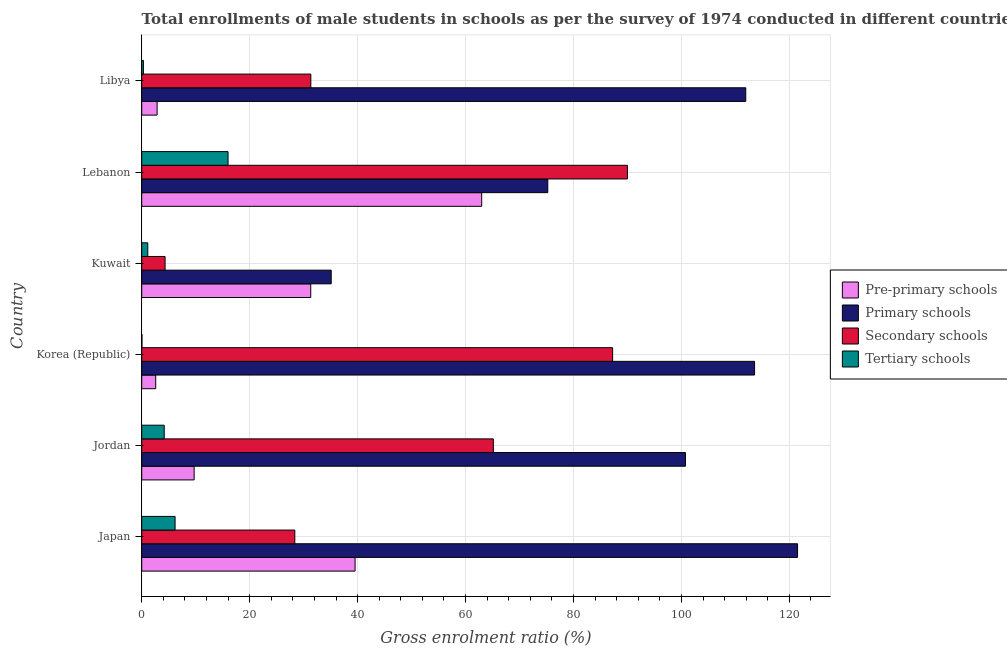How many groups of bars are there?
Offer a very short reply. 6. How many bars are there on the 5th tick from the top?
Your answer should be compact. 4. In how many cases, is the number of bars for a given country not equal to the number of legend labels?
Keep it short and to the point. 0. What is the gross enrolment ratio(male) in pre-primary schools in Jordan?
Offer a terse response. 9.71. Across all countries, what is the maximum gross enrolment ratio(male) in pre-primary schools?
Your answer should be very brief. 62.99. Across all countries, what is the minimum gross enrolment ratio(male) in pre-primary schools?
Provide a short and direct response. 2.59. In which country was the gross enrolment ratio(male) in secondary schools maximum?
Provide a short and direct response. Lebanon. In which country was the gross enrolment ratio(male) in tertiary schools minimum?
Ensure brevity in your answer.  Korea (Republic). What is the total gross enrolment ratio(male) in pre-primary schools in the graph?
Offer a terse response. 149. What is the difference between the gross enrolment ratio(male) in tertiary schools in Japan and that in Lebanon?
Give a very brief answer. -9.81. What is the difference between the gross enrolment ratio(male) in primary schools in Japan and the gross enrolment ratio(male) in pre-primary schools in Korea (Republic)?
Your answer should be compact. 118.92. What is the average gross enrolment ratio(male) in secondary schools per country?
Ensure brevity in your answer.  51.07. What is the difference between the gross enrolment ratio(male) in tertiary schools and gross enrolment ratio(male) in secondary schools in Korea (Republic)?
Your answer should be compact. -87.21. What is the ratio of the gross enrolment ratio(male) in tertiary schools in Japan to that in Jordan?
Provide a succinct answer. 1.48. Is the gross enrolment ratio(male) in tertiary schools in Jordan less than that in Lebanon?
Offer a very short reply. Yes. Is the difference between the gross enrolment ratio(male) in primary schools in Korea (Republic) and Kuwait greater than the difference between the gross enrolment ratio(male) in pre-primary schools in Korea (Republic) and Kuwait?
Offer a terse response. Yes. What is the difference between the highest and the second highest gross enrolment ratio(male) in pre-primary schools?
Your answer should be compact. 23.46. What is the difference between the highest and the lowest gross enrolment ratio(male) in tertiary schools?
Keep it short and to the point. 15.95. What does the 1st bar from the top in Jordan represents?
Your answer should be compact. Tertiary schools. What does the 4th bar from the bottom in Korea (Republic) represents?
Ensure brevity in your answer.  Tertiary schools. Is it the case that in every country, the sum of the gross enrolment ratio(male) in pre-primary schools and gross enrolment ratio(male) in primary schools is greater than the gross enrolment ratio(male) in secondary schools?
Make the answer very short. Yes. How many bars are there?
Provide a succinct answer. 24. Are the values on the major ticks of X-axis written in scientific E-notation?
Offer a terse response. No. Does the graph contain grids?
Make the answer very short. Yes. How many legend labels are there?
Your answer should be very brief. 4. How are the legend labels stacked?
Your response must be concise. Vertical. What is the title of the graph?
Offer a very short reply. Total enrollments of male students in schools as per the survey of 1974 conducted in different countries. Does "WFP" appear as one of the legend labels in the graph?
Offer a very short reply. No. What is the label or title of the X-axis?
Ensure brevity in your answer.  Gross enrolment ratio (%). What is the label or title of the Y-axis?
Your answer should be compact. Country. What is the Gross enrolment ratio (%) in Pre-primary schools in Japan?
Offer a very short reply. 39.53. What is the Gross enrolment ratio (%) in Primary schools in Japan?
Ensure brevity in your answer.  121.52. What is the Gross enrolment ratio (%) in Secondary schools in Japan?
Offer a terse response. 28.36. What is the Gross enrolment ratio (%) of Tertiary schools in Japan?
Keep it short and to the point. 6.18. What is the Gross enrolment ratio (%) in Pre-primary schools in Jordan?
Offer a very short reply. 9.71. What is the Gross enrolment ratio (%) of Primary schools in Jordan?
Keep it short and to the point. 100.75. What is the Gross enrolment ratio (%) in Secondary schools in Jordan?
Make the answer very short. 65.15. What is the Gross enrolment ratio (%) of Tertiary schools in Jordan?
Give a very brief answer. 4.17. What is the Gross enrolment ratio (%) in Pre-primary schools in Korea (Republic)?
Your answer should be compact. 2.59. What is the Gross enrolment ratio (%) of Primary schools in Korea (Republic)?
Offer a terse response. 113.55. What is the Gross enrolment ratio (%) of Secondary schools in Korea (Republic)?
Ensure brevity in your answer.  87.25. What is the Gross enrolment ratio (%) in Tertiary schools in Korea (Republic)?
Your answer should be compact. 0.04. What is the Gross enrolment ratio (%) of Pre-primary schools in Kuwait?
Make the answer very short. 31.32. What is the Gross enrolment ratio (%) of Primary schools in Kuwait?
Ensure brevity in your answer.  35.11. What is the Gross enrolment ratio (%) in Secondary schools in Kuwait?
Ensure brevity in your answer.  4.33. What is the Gross enrolment ratio (%) of Tertiary schools in Kuwait?
Your response must be concise. 1.12. What is the Gross enrolment ratio (%) of Pre-primary schools in Lebanon?
Offer a very short reply. 62.99. What is the Gross enrolment ratio (%) in Primary schools in Lebanon?
Make the answer very short. 75.24. What is the Gross enrolment ratio (%) in Secondary schools in Lebanon?
Offer a very short reply. 89.99. What is the Gross enrolment ratio (%) in Tertiary schools in Lebanon?
Your response must be concise. 16. What is the Gross enrolment ratio (%) of Pre-primary schools in Libya?
Your answer should be very brief. 2.85. What is the Gross enrolment ratio (%) in Primary schools in Libya?
Provide a succinct answer. 111.92. What is the Gross enrolment ratio (%) in Secondary schools in Libya?
Your response must be concise. 31.33. What is the Gross enrolment ratio (%) in Tertiary schools in Libya?
Provide a succinct answer. 0.32. Across all countries, what is the maximum Gross enrolment ratio (%) of Pre-primary schools?
Your answer should be compact. 62.99. Across all countries, what is the maximum Gross enrolment ratio (%) of Primary schools?
Your response must be concise. 121.52. Across all countries, what is the maximum Gross enrolment ratio (%) of Secondary schools?
Offer a terse response. 89.99. Across all countries, what is the maximum Gross enrolment ratio (%) in Tertiary schools?
Give a very brief answer. 16. Across all countries, what is the minimum Gross enrolment ratio (%) of Pre-primary schools?
Provide a succinct answer. 2.59. Across all countries, what is the minimum Gross enrolment ratio (%) in Primary schools?
Your answer should be very brief. 35.11. Across all countries, what is the minimum Gross enrolment ratio (%) of Secondary schools?
Provide a short and direct response. 4.33. Across all countries, what is the minimum Gross enrolment ratio (%) of Tertiary schools?
Offer a very short reply. 0.04. What is the total Gross enrolment ratio (%) of Pre-primary schools in the graph?
Your response must be concise. 149. What is the total Gross enrolment ratio (%) in Primary schools in the graph?
Make the answer very short. 558.09. What is the total Gross enrolment ratio (%) of Secondary schools in the graph?
Your response must be concise. 306.42. What is the total Gross enrolment ratio (%) of Tertiary schools in the graph?
Your answer should be compact. 27.83. What is the difference between the Gross enrolment ratio (%) in Pre-primary schools in Japan and that in Jordan?
Offer a terse response. 29.82. What is the difference between the Gross enrolment ratio (%) in Primary schools in Japan and that in Jordan?
Your answer should be very brief. 20.77. What is the difference between the Gross enrolment ratio (%) of Secondary schools in Japan and that in Jordan?
Offer a very short reply. -36.78. What is the difference between the Gross enrolment ratio (%) of Tertiary schools in Japan and that in Jordan?
Your answer should be compact. 2.01. What is the difference between the Gross enrolment ratio (%) of Pre-primary schools in Japan and that in Korea (Republic)?
Provide a succinct answer. 36.94. What is the difference between the Gross enrolment ratio (%) of Primary schools in Japan and that in Korea (Republic)?
Keep it short and to the point. 7.97. What is the difference between the Gross enrolment ratio (%) of Secondary schools in Japan and that in Korea (Republic)?
Offer a very short reply. -58.89. What is the difference between the Gross enrolment ratio (%) in Tertiary schools in Japan and that in Korea (Republic)?
Provide a short and direct response. 6.14. What is the difference between the Gross enrolment ratio (%) of Pre-primary schools in Japan and that in Kuwait?
Ensure brevity in your answer.  8.21. What is the difference between the Gross enrolment ratio (%) in Primary schools in Japan and that in Kuwait?
Keep it short and to the point. 86.41. What is the difference between the Gross enrolment ratio (%) in Secondary schools in Japan and that in Kuwait?
Your answer should be very brief. 24.04. What is the difference between the Gross enrolment ratio (%) of Tertiary schools in Japan and that in Kuwait?
Provide a short and direct response. 5.06. What is the difference between the Gross enrolment ratio (%) of Pre-primary schools in Japan and that in Lebanon?
Ensure brevity in your answer.  -23.46. What is the difference between the Gross enrolment ratio (%) in Primary schools in Japan and that in Lebanon?
Your answer should be compact. 46.28. What is the difference between the Gross enrolment ratio (%) in Secondary schools in Japan and that in Lebanon?
Your response must be concise. -61.63. What is the difference between the Gross enrolment ratio (%) in Tertiary schools in Japan and that in Lebanon?
Provide a succinct answer. -9.81. What is the difference between the Gross enrolment ratio (%) in Pre-primary schools in Japan and that in Libya?
Offer a terse response. 36.68. What is the difference between the Gross enrolment ratio (%) of Primary schools in Japan and that in Libya?
Your answer should be very brief. 9.6. What is the difference between the Gross enrolment ratio (%) of Secondary schools in Japan and that in Libya?
Ensure brevity in your answer.  -2.97. What is the difference between the Gross enrolment ratio (%) in Tertiary schools in Japan and that in Libya?
Make the answer very short. 5.87. What is the difference between the Gross enrolment ratio (%) of Pre-primary schools in Jordan and that in Korea (Republic)?
Your answer should be compact. 7.12. What is the difference between the Gross enrolment ratio (%) in Primary schools in Jordan and that in Korea (Republic)?
Give a very brief answer. -12.8. What is the difference between the Gross enrolment ratio (%) of Secondary schools in Jordan and that in Korea (Republic)?
Your response must be concise. -22.1. What is the difference between the Gross enrolment ratio (%) in Tertiary schools in Jordan and that in Korea (Republic)?
Provide a succinct answer. 4.13. What is the difference between the Gross enrolment ratio (%) in Pre-primary schools in Jordan and that in Kuwait?
Make the answer very short. -21.61. What is the difference between the Gross enrolment ratio (%) of Primary schools in Jordan and that in Kuwait?
Offer a very short reply. 65.64. What is the difference between the Gross enrolment ratio (%) of Secondary schools in Jordan and that in Kuwait?
Your answer should be compact. 60.82. What is the difference between the Gross enrolment ratio (%) in Tertiary schools in Jordan and that in Kuwait?
Your answer should be very brief. 3.05. What is the difference between the Gross enrolment ratio (%) in Pre-primary schools in Jordan and that in Lebanon?
Offer a terse response. -53.28. What is the difference between the Gross enrolment ratio (%) of Primary schools in Jordan and that in Lebanon?
Provide a succinct answer. 25.51. What is the difference between the Gross enrolment ratio (%) in Secondary schools in Jordan and that in Lebanon?
Provide a succinct answer. -24.84. What is the difference between the Gross enrolment ratio (%) in Tertiary schools in Jordan and that in Lebanon?
Make the answer very short. -11.83. What is the difference between the Gross enrolment ratio (%) of Pre-primary schools in Jordan and that in Libya?
Provide a short and direct response. 6.86. What is the difference between the Gross enrolment ratio (%) in Primary schools in Jordan and that in Libya?
Your answer should be compact. -11.17. What is the difference between the Gross enrolment ratio (%) of Secondary schools in Jordan and that in Libya?
Make the answer very short. 33.82. What is the difference between the Gross enrolment ratio (%) of Tertiary schools in Jordan and that in Libya?
Provide a short and direct response. 3.85. What is the difference between the Gross enrolment ratio (%) of Pre-primary schools in Korea (Republic) and that in Kuwait?
Provide a short and direct response. -28.72. What is the difference between the Gross enrolment ratio (%) in Primary schools in Korea (Republic) and that in Kuwait?
Your response must be concise. 78.44. What is the difference between the Gross enrolment ratio (%) in Secondary schools in Korea (Republic) and that in Kuwait?
Keep it short and to the point. 82.92. What is the difference between the Gross enrolment ratio (%) in Tertiary schools in Korea (Republic) and that in Kuwait?
Provide a short and direct response. -1.08. What is the difference between the Gross enrolment ratio (%) of Pre-primary schools in Korea (Republic) and that in Lebanon?
Offer a terse response. -60.4. What is the difference between the Gross enrolment ratio (%) of Primary schools in Korea (Republic) and that in Lebanon?
Provide a succinct answer. 38.31. What is the difference between the Gross enrolment ratio (%) of Secondary schools in Korea (Republic) and that in Lebanon?
Make the answer very short. -2.74. What is the difference between the Gross enrolment ratio (%) in Tertiary schools in Korea (Republic) and that in Lebanon?
Your answer should be very brief. -15.95. What is the difference between the Gross enrolment ratio (%) of Pre-primary schools in Korea (Republic) and that in Libya?
Your answer should be very brief. -0.26. What is the difference between the Gross enrolment ratio (%) of Primary schools in Korea (Republic) and that in Libya?
Your answer should be very brief. 1.63. What is the difference between the Gross enrolment ratio (%) in Secondary schools in Korea (Republic) and that in Libya?
Your answer should be compact. 55.92. What is the difference between the Gross enrolment ratio (%) in Tertiary schools in Korea (Republic) and that in Libya?
Your answer should be very brief. -0.27. What is the difference between the Gross enrolment ratio (%) in Pre-primary schools in Kuwait and that in Lebanon?
Keep it short and to the point. -31.68. What is the difference between the Gross enrolment ratio (%) of Primary schools in Kuwait and that in Lebanon?
Provide a short and direct response. -40.13. What is the difference between the Gross enrolment ratio (%) in Secondary schools in Kuwait and that in Lebanon?
Keep it short and to the point. -85.67. What is the difference between the Gross enrolment ratio (%) in Tertiary schools in Kuwait and that in Lebanon?
Your response must be concise. -14.87. What is the difference between the Gross enrolment ratio (%) of Pre-primary schools in Kuwait and that in Libya?
Keep it short and to the point. 28.47. What is the difference between the Gross enrolment ratio (%) in Primary schools in Kuwait and that in Libya?
Offer a terse response. -76.81. What is the difference between the Gross enrolment ratio (%) of Secondary schools in Kuwait and that in Libya?
Provide a short and direct response. -27.01. What is the difference between the Gross enrolment ratio (%) of Tertiary schools in Kuwait and that in Libya?
Provide a succinct answer. 0.81. What is the difference between the Gross enrolment ratio (%) in Pre-primary schools in Lebanon and that in Libya?
Offer a very short reply. 60.14. What is the difference between the Gross enrolment ratio (%) of Primary schools in Lebanon and that in Libya?
Ensure brevity in your answer.  -36.68. What is the difference between the Gross enrolment ratio (%) of Secondary schools in Lebanon and that in Libya?
Your answer should be very brief. 58.66. What is the difference between the Gross enrolment ratio (%) of Tertiary schools in Lebanon and that in Libya?
Your response must be concise. 15.68. What is the difference between the Gross enrolment ratio (%) in Pre-primary schools in Japan and the Gross enrolment ratio (%) in Primary schools in Jordan?
Offer a very short reply. -61.22. What is the difference between the Gross enrolment ratio (%) of Pre-primary schools in Japan and the Gross enrolment ratio (%) of Secondary schools in Jordan?
Provide a succinct answer. -25.62. What is the difference between the Gross enrolment ratio (%) of Pre-primary schools in Japan and the Gross enrolment ratio (%) of Tertiary schools in Jordan?
Give a very brief answer. 35.36. What is the difference between the Gross enrolment ratio (%) in Primary schools in Japan and the Gross enrolment ratio (%) in Secondary schools in Jordan?
Ensure brevity in your answer.  56.37. What is the difference between the Gross enrolment ratio (%) in Primary schools in Japan and the Gross enrolment ratio (%) in Tertiary schools in Jordan?
Your answer should be very brief. 117.35. What is the difference between the Gross enrolment ratio (%) of Secondary schools in Japan and the Gross enrolment ratio (%) of Tertiary schools in Jordan?
Provide a short and direct response. 24.2. What is the difference between the Gross enrolment ratio (%) in Pre-primary schools in Japan and the Gross enrolment ratio (%) in Primary schools in Korea (Republic)?
Offer a very short reply. -74.02. What is the difference between the Gross enrolment ratio (%) in Pre-primary schools in Japan and the Gross enrolment ratio (%) in Secondary schools in Korea (Republic)?
Your answer should be very brief. -47.72. What is the difference between the Gross enrolment ratio (%) in Pre-primary schools in Japan and the Gross enrolment ratio (%) in Tertiary schools in Korea (Republic)?
Your answer should be compact. 39.49. What is the difference between the Gross enrolment ratio (%) in Primary schools in Japan and the Gross enrolment ratio (%) in Secondary schools in Korea (Republic)?
Give a very brief answer. 34.27. What is the difference between the Gross enrolment ratio (%) of Primary schools in Japan and the Gross enrolment ratio (%) of Tertiary schools in Korea (Republic)?
Provide a short and direct response. 121.48. What is the difference between the Gross enrolment ratio (%) in Secondary schools in Japan and the Gross enrolment ratio (%) in Tertiary schools in Korea (Republic)?
Give a very brief answer. 28.32. What is the difference between the Gross enrolment ratio (%) of Pre-primary schools in Japan and the Gross enrolment ratio (%) of Primary schools in Kuwait?
Ensure brevity in your answer.  4.42. What is the difference between the Gross enrolment ratio (%) of Pre-primary schools in Japan and the Gross enrolment ratio (%) of Secondary schools in Kuwait?
Your answer should be compact. 35.2. What is the difference between the Gross enrolment ratio (%) of Pre-primary schools in Japan and the Gross enrolment ratio (%) of Tertiary schools in Kuwait?
Ensure brevity in your answer.  38.41. What is the difference between the Gross enrolment ratio (%) of Primary schools in Japan and the Gross enrolment ratio (%) of Secondary schools in Kuwait?
Offer a very short reply. 117.19. What is the difference between the Gross enrolment ratio (%) in Primary schools in Japan and the Gross enrolment ratio (%) in Tertiary schools in Kuwait?
Make the answer very short. 120.4. What is the difference between the Gross enrolment ratio (%) in Secondary schools in Japan and the Gross enrolment ratio (%) in Tertiary schools in Kuwait?
Provide a succinct answer. 27.24. What is the difference between the Gross enrolment ratio (%) in Pre-primary schools in Japan and the Gross enrolment ratio (%) in Primary schools in Lebanon?
Ensure brevity in your answer.  -35.71. What is the difference between the Gross enrolment ratio (%) in Pre-primary schools in Japan and the Gross enrolment ratio (%) in Secondary schools in Lebanon?
Your response must be concise. -50.46. What is the difference between the Gross enrolment ratio (%) of Pre-primary schools in Japan and the Gross enrolment ratio (%) of Tertiary schools in Lebanon?
Provide a succinct answer. 23.54. What is the difference between the Gross enrolment ratio (%) in Primary schools in Japan and the Gross enrolment ratio (%) in Secondary schools in Lebanon?
Offer a terse response. 31.52. What is the difference between the Gross enrolment ratio (%) in Primary schools in Japan and the Gross enrolment ratio (%) in Tertiary schools in Lebanon?
Ensure brevity in your answer.  105.52. What is the difference between the Gross enrolment ratio (%) of Secondary schools in Japan and the Gross enrolment ratio (%) of Tertiary schools in Lebanon?
Make the answer very short. 12.37. What is the difference between the Gross enrolment ratio (%) of Pre-primary schools in Japan and the Gross enrolment ratio (%) of Primary schools in Libya?
Provide a succinct answer. -72.39. What is the difference between the Gross enrolment ratio (%) in Pre-primary schools in Japan and the Gross enrolment ratio (%) in Secondary schools in Libya?
Offer a terse response. 8.2. What is the difference between the Gross enrolment ratio (%) in Pre-primary schools in Japan and the Gross enrolment ratio (%) in Tertiary schools in Libya?
Offer a very short reply. 39.22. What is the difference between the Gross enrolment ratio (%) of Primary schools in Japan and the Gross enrolment ratio (%) of Secondary schools in Libya?
Your answer should be very brief. 90.18. What is the difference between the Gross enrolment ratio (%) in Primary schools in Japan and the Gross enrolment ratio (%) in Tertiary schools in Libya?
Make the answer very short. 121.2. What is the difference between the Gross enrolment ratio (%) of Secondary schools in Japan and the Gross enrolment ratio (%) of Tertiary schools in Libya?
Offer a very short reply. 28.05. What is the difference between the Gross enrolment ratio (%) in Pre-primary schools in Jordan and the Gross enrolment ratio (%) in Primary schools in Korea (Republic)?
Offer a very short reply. -103.84. What is the difference between the Gross enrolment ratio (%) in Pre-primary schools in Jordan and the Gross enrolment ratio (%) in Secondary schools in Korea (Republic)?
Offer a very short reply. -77.54. What is the difference between the Gross enrolment ratio (%) in Pre-primary schools in Jordan and the Gross enrolment ratio (%) in Tertiary schools in Korea (Republic)?
Your answer should be compact. 9.67. What is the difference between the Gross enrolment ratio (%) of Primary schools in Jordan and the Gross enrolment ratio (%) of Secondary schools in Korea (Republic)?
Offer a very short reply. 13.5. What is the difference between the Gross enrolment ratio (%) of Primary schools in Jordan and the Gross enrolment ratio (%) of Tertiary schools in Korea (Republic)?
Your response must be concise. 100.71. What is the difference between the Gross enrolment ratio (%) in Secondary schools in Jordan and the Gross enrolment ratio (%) in Tertiary schools in Korea (Republic)?
Offer a terse response. 65.11. What is the difference between the Gross enrolment ratio (%) in Pre-primary schools in Jordan and the Gross enrolment ratio (%) in Primary schools in Kuwait?
Your response must be concise. -25.4. What is the difference between the Gross enrolment ratio (%) in Pre-primary schools in Jordan and the Gross enrolment ratio (%) in Secondary schools in Kuwait?
Offer a very short reply. 5.38. What is the difference between the Gross enrolment ratio (%) in Pre-primary schools in Jordan and the Gross enrolment ratio (%) in Tertiary schools in Kuwait?
Your answer should be compact. 8.59. What is the difference between the Gross enrolment ratio (%) in Primary schools in Jordan and the Gross enrolment ratio (%) in Secondary schools in Kuwait?
Make the answer very short. 96.42. What is the difference between the Gross enrolment ratio (%) in Primary schools in Jordan and the Gross enrolment ratio (%) in Tertiary schools in Kuwait?
Provide a succinct answer. 99.63. What is the difference between the Gross enrolment ratio (%) in Secondary schools in Jordan and the Gross enrolment ratio (%) in Tertiary schools in Kuwait?
Your answer should be compact. 64.03. What is the difference between the Gross enrolment ratio (%) in Pre-primary schools in Jordan and the Gross enrolment ratio (%) in Primary schools in Lebanon?
Make the answer very short. -65.53. What is the difference between the Gross enrolment ratio (%) in Pre-primary schools in Jordan and the Gross enrolment ratio (%) in Secondary schools in Lebanon?
Offer a terse response. -80.28. What is the difference between the Gross enrolment ratio (%) of Pre-primary schools in Jordan and the Gross enrolment ratio (%) of Tertiary schools in Lebanon?
Make the answer very short. -6.28. What is the difference between the Gross enrolment ratio (%) of Primary schools in Jordan and the Gross enrolment ratio (%) of Secondary schools in Lebanon?
Make the answer very short. 10.76. What is the difference between the Gross enrolment ratio (%) of Primary schools in Jordan and the Gross enrolment ratio (%) of Tertiary schools in Lebanon?
Your answer should be very brief. 84.75. What is the difference between the Gross enrolment ratio (%) in Secondary schools in Jordan and the Gross enrolment ratio (%) in Tertiary schools in Lebanon?
Offer a very short reply. 49.15. What is the difference between the Gross enrolment ratio (%) in Pre-primary schools in Jordan and the Gross enrolment ratio (%) in Primary schools in Libya?
Make the answer very short. -102.21. What is the difference between the Gross enrolment ratio (%) in Pre-primary schools in Jordan and the Gross enrolment ratio (%) in Secondary schools in Libya?
Give a very brief answer. -21.62. What is the difference between the Gross enrolment ratio (%) in Pre-primary schools in Jordan and the Gross enrolment ratio (%) in Tertiary schools in Libya?
Keep it short and to the point. 9.4. What is the difference between the Gross enrolment ratio (%) of Primary schools in Jordan and the Gross enrolment ratio (%) of Secondary schools in Libya?
Offer a very short reply. 69.42. What is the difference between the Gross enrolment ratio (%) in Primary schools in Jordan and the Gross enrolment ratio (%) in Tertiary schools in Libya?
Offer a terse response. 100.44. What is the difference between the Gross enrolment ratio (%) of Secondary schools in Jordan and the Gross enrolment ratio (%) of Tertiary schools in Libya?
Your answer should be compact. 64.83. What is the difference between the Gross enrolment ratio (%) of Pre-primary schools in Korea (Republic) and the Gross enrolment ratio (%) of Primary schools in Kuwait?
Offer a terse response. -32.52. What is the difference between the Gross enrolment ratio (%) of Pre-primary schools in Korea (Republic) and the Gross enrolment ratio (%) of Secondary schools in Kuwait?
Offer a very short reply. -1.73. What is the difference between the Gross enrolment ratio (%) of Pre-primary schools in Korea (Republic) and the Gross enrolment ratio (%) of Tertiary schools in Kuwait?
Give a very brief answer. 1.47. What is the difference between the Gross enrolment ratio (%) of Primary schools in Korea (Republic) and the Gross enrolment ratio (%) of Secondary schools in Kuwait?
Offer a very short reply. 109.22. What is the difference between the Gross enrolment ratio (%) in Primary schools in Korea (Republic) and the Gross enrolment ratio (%) in Tertiary schools in Kuwait?
Provide a succinct answer. 112.43. What is the difference between the Gross enrolment ratio (%) in Secondary schools in Korea (Republic) and the Gross enrolment ratio (%) in Tertiary schools in Kuwait?
Provide a short and direct response. 86.13. What is the difference between the Gross enrolment ratio (%) in Pre-primary schools in Korea (Republic) and the Gross enrolment ratio (%) in Primary schools in Lebanon?
Keep it short and to the point. -72.64. What is the difference between the Gross enrolment ratio (%) in Pre-primary schools in Korea (Republic) and the Gross enrolment ratio (%) in Secondary schools in Lebanon?
Your response must be concise. -87.4. What is the difference between the Gross enrolment ratio (%) of Pre-primary schools in Korea (Republic) and the Gross enrolment ratio (%) of Tertiary schools in Lebanon?
Provide a succinct answer. -13.4. What is the difference between the Gross enrolment ratio (%) of Primary schools in Korea (Republic) and the Gross enrolment ratio (%) of Secondary schools in Lebanon?
Offer a very short reply. 23.56. What is the difference between the Gross enrolment ratio (%) in Primary schools in Korea (Republic) and the Gross enrolment ratio (%) in Tertiary schools in Lebanon?
Offer a very short reply. 97.56. What is the difference between the Gross enrolment ratio (%) in Secondary schools in Korea (Republic) and the Gross enrolment ratio (%) in Tertiary schools in Lebanon?
Offer a terse response. 71.25. What is the difference between the Gross enrolment ratio (%) of Pre-primary schools in Korea (Republic) and the Gross enrolment ratio (%) of Primary schools in Libya?
Provide a short and direct response. -109.33. What is the difference between the Gross enrolment ratio (%) of Pre-primary schools in Korea (Republic) and the Gross enrolment ratio (%) of Secondary schools in Libya?
Offer a terse response. -28.74. What is the difference between the Gross enrolment ratio (%) in Pre-primary schools in Korea (Republic) and the Gross enrolment ratio (%) in Tertiary schools in Libya?
Ensure brevity in your answer.  2.28. What is the difference between the Gross enrolment ratio (%) of Primary schools in Korea (Republic) and the Gross enrolment ratio (%) of Secondary schools in Libya?
Provide a succinct answer. 82.22. What is the difference between the Gross enrolment ratio (%) in Primary schools in Korea (Republic) and the Gross enrolment ratio (%) in Tertiary schools in Libya?
Provide a short and direct response. 113.24. What is the difference between the Gross enrolment ratio (%) of Secondary schools in Korea (Republic) and the Gross enrolment ratio (%) of Tertiary schools in Libya?
Offer a very short reply. 86.94. What is the difference between the Gross enrolment ratio (%) in Pre-primary schools in Kuwait and the Gross enrolment ratio (%) in Primary schools in Lebanon?
Your answer should be compact. -43.92. What is the difference between the Gross enrolment ratio (%) in Pre-primary schools in Kuwait and the Gross enrolment ratio (%) in Secondary schools in Lebanon?
Your answer should be very brief. -58.68. What is the difference between the Gross enrolment ratio (%) of Pre-primary schools in Kuwait and the Gross enrolment ratio (%) of Tertiary schools in Lebanon?
Provide a succinct answer. 15.32. What is the difference between the Gross enrolment ratio (%) in Primary schools in Kuwait and the Gross enrolment ratio (%) in Secondary schools in Lebanon?
Your answer should be very brief. -54.88. What is the difference between the Gross enrolment ratio (%) of Primary schools in Kuwait and the Gross enrolment ratio (%) of Tertiary schools in Lebanon?
Your answer should be very brief. 19.11. What is the difference between the Gross enrolment ratio (%) of Secondary schools in Kuwait and the Gross enrolment ratio (%) of Tertiary schools in Lebanon?
Your response must be concise. -11.67. What is the difference between the Gross enrolment ratio (%) in Pre-primary schools in Kuwait and the Gross enrolment ratio (%) in Primary schools in Libya?
Offer a very short reply. -80.6. What is the difference between the Gross enrolment ratio (%) in Pre-primary schools in Kuwait and the Gross enrolment ratio (%) in Secondary schools in Libya?
Give a very brief answer. -0.02. What is the difference between the Gross enrolment ratio (%) in Pre-primary schools in Kuwait and the Gross enrolment ratio (%) in Tertiary schools in Libya?
Your answer should be compact. 31. What is the difference between the Gross enrolment ratio (%) in Primary schools in Kuwait and the Gross enrolment ratio (%) in Secondary schools in Libya?
Ensure brevity in your answer.  3.78. What is the difference between the Gross enrolment ratio (%) in Primary schools in Kuwait and the Gross enrolment ratio (%) in Tertiary schools in Libya?
Provide a short and direct response. 34.79. What is the difference between the Gross enrolment ratio (%) of Secondary schools in Kuwait and the Gross enrolment ratio (%) of Tertiary schools in Libya?
Provide a short and direct response. 4.01. What is the difference between the Gross enrolment ratio (%) in Pre-primary schools in Lebanon and the Gross enrolment ratio (%) in Primary schools in Libya?
Your response must be concise. -48.93. What is the difference between the Gross enrolment ratio (%) of Pre-primary schools in Lebanon and the Gross enrolment ratio (%) of Secondary schools in Libya?
Keep it short and to the point. 31.66. What is the difference between the Gross enrolment ratio (%) in Pre-primary schools in Lebanon and the Gross enrolment ratio (%) in Tertiary schools in Libya?
Provide a succinct answer. 62.68. What is the difference between the Gross enrolment ratio (%) in Primary schools in Lebanon and the Gross enrolment ratio (%) in Secondary schools in Libya?
Ensure brevity in your answer.  43.9. What is the difference between the Gross enrolment ratio (%) of Primary schools in Lebanon and the Gross enrolment ratio (%) of Tertiary schools in Libya?
Give a very brief answer. 74.92. What is the difference between the Gross enrolment ratio (%) in Secondary schools in Lebanon and the Gross enrolment ratio (%) in Tertiary schools in Libya?
Make the answer very short. 89.68. What is the average Gross enrolment ratio (%) of Pre-primary schools per country?
Keep it short and to the point. 24.83. What is the average Gross enrolment ratio (%) in Primary schools per country?
Give a very brief answer. 93.01. What is the average Gross enrolment ratio (%) of Secondary schools per country?
Make the answer very short. 51.07. What is the average Gross enrolment ratio (%) of Tertiary schools per country?
Give a very brief answer. 4.64. What is the difference between the Gross enrolment ratio (%) of Pre-primary schools and Gross enrolment ratio (%) of Primary schools in Japan?
Offer a very short reply. -81.99. What is the difference between the Gross enrolment ratio (%) in Pre-primary schools and Gross enrolment ratio (%) in Secondary schools in Japan?
Keep it short and to the point. 11.17. What is the difference between the Gross enrolment ratio (%) of Pre-primary schools and Gross enrolment ratio (%) of Tertiary schools in Japan?
Provide a succinct answer. 33.35. What is the difference between the Gross enrolment ratio (%) of Primary schools and Gross enrolment ratio (%) of Secondary schools in Japan?
Provide a succinct answer. 93.15. What is the difference between the Gross enrolment ratio (%) of Primary schools and Gross enrolment ratio (%) of Tertiary schools in Japan?
Offer a terse response. 115.34. What is the difference between the Gross enrolment ratio (%) of Secondary schools and Gross enrolment ratio (%) of Tertiary schools in Japan?
Offer a very short reply. 22.18. What is the difference between the Gross enrolment ratio (%) of Pre-primary schools and Gross enrolment ratio (%) of Primary schools in Jordan?
Make the answer very short. -91.04. What is the difference between the Gross enrolment ratio (%) of Pre-primary schools and Gross enrolment ratio (%) of Secondary schools in Jordan?
Ensure brevity in your answer.  -55.44. What is the difference between the Gross enrolment ratio (%) in Pre-primary schools and Gross enrolment ratio (%) in Tertiary schools in Jordan?
Ensure brevity in your answer.  5.54. What is the difference between the Gross enrolment ratio (%) in Primary schools and Gross enrolment ratio (%) in Secondary schools in Jordan?
Give a very brief answer. 35.6. What is the difference between the Gross enrolment ratio (%) of Primary schools and Gross enrolment ratio (%) of Tertiary schools in Jordan?
Your answer should be very brief. 96.58. What is the difference between the Gross enrolment ratio (%) in Secondary schools and Gross enrolment ratio (%) in Tertiary schools in Jordan?
Provide a succinct answer. 60.98. What is the difference between the Gross enrolment ratio (%) in Pre-primary schools and Gross enrolment ratio (%) in Primary schools in Korea (Republic)?
Keep it short and to the point. -110.96. What is the difference between the Gross enrolment ratio (%) in Pre-primary schools and Gross enrolment ratio (%) in Secondary schools in Korea (Republic)?
Ensure brevity in your answer.  -84.66. What is the difference between the Gross enrolment ratio (%) in Pre-primary schools and Gross enrolment ratio (%) in Tertiary schools in Korea (Republic)?
Offer a terse response. 2.55. What is the difference between the Gross enrolment ratio (%) of Primary schools and Gross enrolment ratio (%) of Secondary schools in Korea (Republic)?
Your response must be concise. 26.3. What is the difference between the Gross enrolment ratio (%) in Primary schools and Gross enrolment ratio (%) in Tertiary schools in Korea (Republic)?
Provide a short and direct response. 113.51. What is the difference between the Gross enrolment ratio (%) in Secondary schools and Gross enrolment ratio (%) in Tertiary schools in Korea (Republic)?
Your answer should be very brief. 87.21. What is the difference between the Gross enrolment ratio (%) in Pre-primary schools and Gross enrolment ratio (%) in Primary schools in Kuwait?
Ensure brevity in your answer.  -3.79. What is the difference between the Gross enrolment ratio (%) in Pre-primary schools and Gross enrolment ratio (%) in Secondary schools in Kuwait?
Provide a succinct answer. 26.99. What is the difference between the Gross enrolment ratio (%) of Pre-primary schools and Gross enrolment ratio (%) of Tertiary schools in Kuwait?
Ensure brevity in your answer.  30.2. What is the difference between the Gross enrolment ratio (%) of Primary schools and Gross enrolment ratio (%) of Secondary schools in Kuwait?
Your response must be concise. 30.78. What is the difference between the Gross enrolment ratio (%) in Primary schools and Gross enrolment ratio (%) in Tertiary schools in Kuwait?
Offer a terse response. 33.99. What is the difference between the Gross enrolment ratio (%) of Secondary schools and Gross enrolment ratio (%) of Tertiary schools in Kuwait?
Your answer should be compact. 3.21. What is the difference between the Gross enrolment ratio (%) in Pre-primary schools and Gross enrolment ratio (%) in Primary schools in Lebanon?
Provide a succinct answer. -12.24. What is the difference between the Gross enrolment ratio (%) of Pre-primary schools and Gross enrolment ratio (%) of Secondary schools in Lebanon?
Your answer should be compact. -27. What is the difference between the Gross enrolment ratio (%) of Pre-primary schools and Gross enrolment ratio (%) of Tertiary schools in Lebanon?
Provide a short and direct response. 47. What is the difference between the Gross enrolment ratio (%) in Primary schools and Gross enrolment ratio (%) in Secondary schools in Lebanon?
Ensure brevity in your answer.  -14.76. What is the difference between the Gross enrolment ratio (%) in Primary schools and Gross enrolment ratio (%) in Tertiary schools in Lebanon?
Give a very brief answer. 59.24. What is the difference between the Gross enrolment ratio (%) of Secondary schools and Gross enrolment ratio (%) of Tertiary schools in Lebanon?
Provide a short and direct response. 74. What is the difference between the Gross enrolment ratio (%) in Pre-primary schools and Gross enrolment ratio (%) in Primary schools in Libya?
Your answer should be compact. -109.07. What is the difference between the Gross enrolment ratio (%) in Pre-primary schools and Gross enrolment ratio (%) in Secondary schools in Libya?
Your answer should be compact. -28.48. What is the difference between the Gross enrolment ratio (%) of Pre-primary schools and Gross enrolment ratio (%) of Tertiary schools in Libya?
Provide a short and direct response. 2.54. What is the difference between the Gross enrolment ratio (%) of Primary schools and Gross enrolment ratio (%) of Secondary schools in Libya?
Provide a succinct answer. 80.59. What is the difference between the Gross enrolment ratio (%) of Primary schools and Gross enrolment ratio (%) of Tertiary schools in Libya?
Offer a very short reply. 111.6. What is the difference between the Gross enrolment ratio (%) in Secondary schools and Gross enrolment ratio (%) in Tertiary schools in Libya?
Provide a short and direct response. 31.02. What is the ratio of the Gross enrolment ratio (%) in Pre-primary schools in Japan to that in Jordan?
Ensure brevity in your answer.  4.07. What is the ratio of the Gross enrolment ratio (%) in Primary schools in Japan to that in Jordan?
Your response must be concise. 1.21. What is the ratio of the Gross enrolment ratio (%) in Secondary schools in Japan to that in Jordan?
Keep it short and to the point. 0.44. What is the ratio of the Gross enrolment ratio (%) of Tertiary schools in Japan to that in Jordan?
Offer a terse response. 1.48. What is the ratio of the Gross enrolment ratio (%) of Pre-primary schools in Japan to that in Korea (Republic)?
Make the answer very short. 15.24. What is the ratio of the Gross enrolment ratio (%) of Primary schools in Japan to that in Korea (Republic)?
Your answer should be compact. 1.07. What is the ratio of the Gross enrolment ratio (%) in Secondary schools in Japan to that in Korea (Republic)?
Ensure brevity in your answer.  0.33. What is the ratio of the Gross enrolment ratio (%) in Tertiary schools in Japan to that in Korea (Republic)?
Offer a terse response. 145.34. What is the ratio of the Gross enrolment ratio (%) in Pre-primary schools in Japan to that in Kuwait?
Give a very brief answer. 1.26. What is the ratio of the Gross enrolment ratio (%) in Primary schools in Japan to that in Kuwait?
Give a very brief answer. 3.46. What is the ratio of the Gross enrolment ratio (%) of Secondary schools in Japan to that in Kuwait?
Offer a terse response. 6.55. What is the ratio of the Gross enrolment ratio (%) in Tertiary schools in Japan to that in Kuwait?
Ensure brevity in your answer.  5.51. What is the ratio of the Gross enrolment ratio (%) of Pre-primary schools in Japan to that in Lebanon?
Offer a terse response. 0.63. What is the ratio of the Gross enrolment ratio (%) in Primary schools in Japan to that in Lebanon?
Provide a short and direct response. 1.62. What is the ratio of the Gross enrolment ratio (%) of Secondary schools in Japan to that in Lebanon?
Make the answer very short. 0.32. What is the ratio of the Gross enrolment ratio (%) in Tertiary schools in Japan to that in Lebanon?
Your response must be concise. 0.39. What is the ratio of the Gross enrolment ratio (%) of Pre-primary schools in Japan to that in Libya?
Provide a succinct answer. 13.86. What is the ratio of the Gross enrolment ratio (%) of Primary schools in Japan to that in Libya?
Offer a very short reply. 1.09. What is the ratio of the Gross enrolment ratio (%) in Secondary schools in Japan to that in Libya?
Provide a short and direct response. 0.91. What is the ratio of the Gross enrolment ratio (%) in Tertiary schools in Japan to that in Libya?
Offer a terse response. 19.6. What is the ratio of the Gross enrolment ratio (%) of Pre-primary schools in Jordan to that in Korea (Republic)?
Offer a terse response. 3.74. What is the ratio of the Gross enrolment ratio (%) of Primary schools in Jordan to that in Korea (Republic)?
Ensure brevity in your answer.  0.89. What is the ratio of the Gross enrolment ratio (%) of Secondary schools in Jordan to that in Korea (Republic)?
Provide a short and direct response. 0.75. What is the ratio of the Gross enrolment ratio (%) in Tertiary schools in Jordan to that in Korea (Republic)?
Give a very brief answer. 98.02. What is the ratio of the Gross enrolment ratio (%) of Pre-primary schools in Jordan to that in Kuwait?
Your answer should be compact. 0.31. What is the ratio of the Gross enrolment ratio (%) in Primary schools in Jordan to that in Kuwait?
Offer a terse response. 2.87. What is the ratio of the Gross enrolment ratio (%) of Secondary schools in Jordan to that in Kuwait?
Give a very brief answer. 15.05. What is the ratio of the Gross enrolment ratio (%) in Tertiary schools in Jordan to that in Kuwait?
Make the answer very short. 3.71. What is the ratio of the Gross enrolment ratio (%) in Pre-primary schools in Jordan to that in Lebanon?
Your answer should be compact. 0.15. What is the ratio of the Gross enrolment ratio (%) in Primary schools in Jordan to that in Lebanon?
Keep it short and to the point. 1.34. What is the ratio of the Gross enrolment ratio (%) in Secondary schools in Jordan to that in Lebanon?
Provide a succinct answer. 0.72. What is the ratio of the Gross enrolment ratio (%) in Tertiary schools in Jordan to that in Lebanon?
Give a very brief answer. 0.26. What is the ratio of the Gross enrolment ratio (%) in Pre-primary schools in Jordan to that in Libya?
Your answer should be compact. 3.41. What is the ratio of the Gross enrolment ratio (%) of Primary schools in Jordan to that in Libya?
Provide a succinct answer. 0.9. What is the ratio of the Gross enrolment ratio (%) in Secondary schools in Jordan to that in Libya?
Give a very brief answer. 2.08. What is the ratio of the Gross enrolment ratio (%) in Tertiary schools in Jordan to that in Libya?
Provide a succinct answer. 13.22. What is the ratio of the Gross enrolment ratio (%) of Pre-primary schools in Korea (Republic) to that in Kuwait?
Give a very brief answer. 0.08. What is the ratio of the Gross enrolment ratio (%) of Primary schools in Korea (Republic) to that in Kuwait?
Your answer should be very brief. 3.23. What is the ratio of the Gross enrolment ratio (%) in Secondary schools in Korea (Republic) to that in Kuwait?
Offer a terse response. 20.16. What is the ratio of the Gross enrolment ratio (%) of Tertiary schools in Korea (Republic) to that in Kuwait?
Your response must be concise. 0.04. What is the ratio of the Gross enrolment ratio (%) of Pre-primary schools in Korea (Republic) to that in Lebanon?
Make the answer very short. 0.04. What is the ratio of the Gross enrolment ratio (%) in Primary schools in Korea (Republic) to that in Lebanon?
Ensure brevity in your answer.  1.51. What is the ratio of the Gross enrolment ratio (%) of Secondary schools in Korea (Republic) to that in Lebanon?
Keep it short and to the point. 0.97. What is the ratio of the Gross enrolment ratio (%) of Tertiary schools in Korea (Republic) to that in Lebanon?
Provide a succinct answer. 0. What is the ratio of the Gross enrolment ratio (%) in Pre-primary schools in Korea (Republic) to that in Libya?
Provide a short and direct response. 0.91. What is the ratio of the Gross enrolment ratio (%) in Primary schools in Korea (Republic) to that in Libya?
Your response must be concise. 1.01. What is the ratio of the Gross enrolment ratio (%) of Secondary schools in Korea (Republic) to that in Libya?
Keep it short and to the point. 2.78. What is the ratio of the Gross enrolment ratio (%) in Tertiary schools in Korea (Republic) to that in Libya?
Your response must be concise. 0.13. What is the ratio of the Gross enrolment ratio (%) of Pre-primary schools in Kuwait to that in Lebanon?
Your response must be concise. 0.5. What is the ratio of the Gross enrolment ratio (%) of Primary schools in Kuwait to that in Lebanon?
Your response must be concise. 0.47. What is the ratio of the Gross enrolment ratio (%) of Secondary schools in Kuwait to that in Lebanon?
Give a very brief answer. 0.05. What is the ratio of the Gross enrolment ratio (%) in Tertiary schools in Kuwait to that in Lebanon?
Ensure brevity in your answer.  0.07. What is the ratio of the Gross enrolment ratio (%) in Pre-primary schools in Kuwait to that in Libya?
Offer a very short reply. 10.98. What is the ratio of the Gross enrolment ratio (%) in Primary schools in Kuwait to that in Libya?
Ensure brevity in your answer.  0.31. What is the ratio of the Gross enrolment ratio (%) in Secondary schools in Kuwait to that in Libya?
Provide a short and direct response. 0.14. What is the ratio of the Gross enrolment ratio (%) in Tertiary schools in Kuwait to that in Libya?
Your answer should be very brief. 3.56. What is the ratio of the Gross enrolment ratio (%) of Pre-primary schools in Lebanon to that in Libya?
Provide a short and direct response. 22.09. What is the ratio of the Gross enrolment ratio (%) in Primary schools in Lebanon to that in Libya?
Keep it short and to the point. 0.67. What is the ratio of the Gross enrolment ratio (%) in Secondary schools in Lebanon to that in Libya?
Make the answer very short. 2.87. What is the ratio of the Gross enrolment ratio (%) in Tertiary schools in Lebanon to that in Libya?
Provide a succinct answer. 50.73. What is the difference between the highest and the second highest Gross enrolment ratio (%) in Pre-primary schools?
Give a very brief answer. 23.46. What is the difference between the highest and the second highest Gross enrolment ratio (%) of Primary schools?
Ensure brevity in your answer.  7.97. What is the difference between the highest and the second highest Gross enrolment ratio (%) in Secondary schools?
Offer a very short reply. 2.74. What is the difference between the highest and the second highest Gross enrolment ratio (%) in Tertiary schools?
Your answer should be compact. 9.81. What is the difference between the highest and the lowest Gross enrolment ratio (%) in Pre-primary schools?
Give a very brief answer. 60.4. What is the difference between the highest and the lowest Gross enrolment ratio (%) of Primary schools?
Provide a short and direct response. 86.41. What is the difference between the highest and the lowest Gross enrolment ratio (%) of Secondary schools?
Your answer should be very brief. 85.67. What is the difference between the highest and the lowest Gross enrolment ratio (%) in Tertiary schools?
Offer a very short reply. 15.95. 